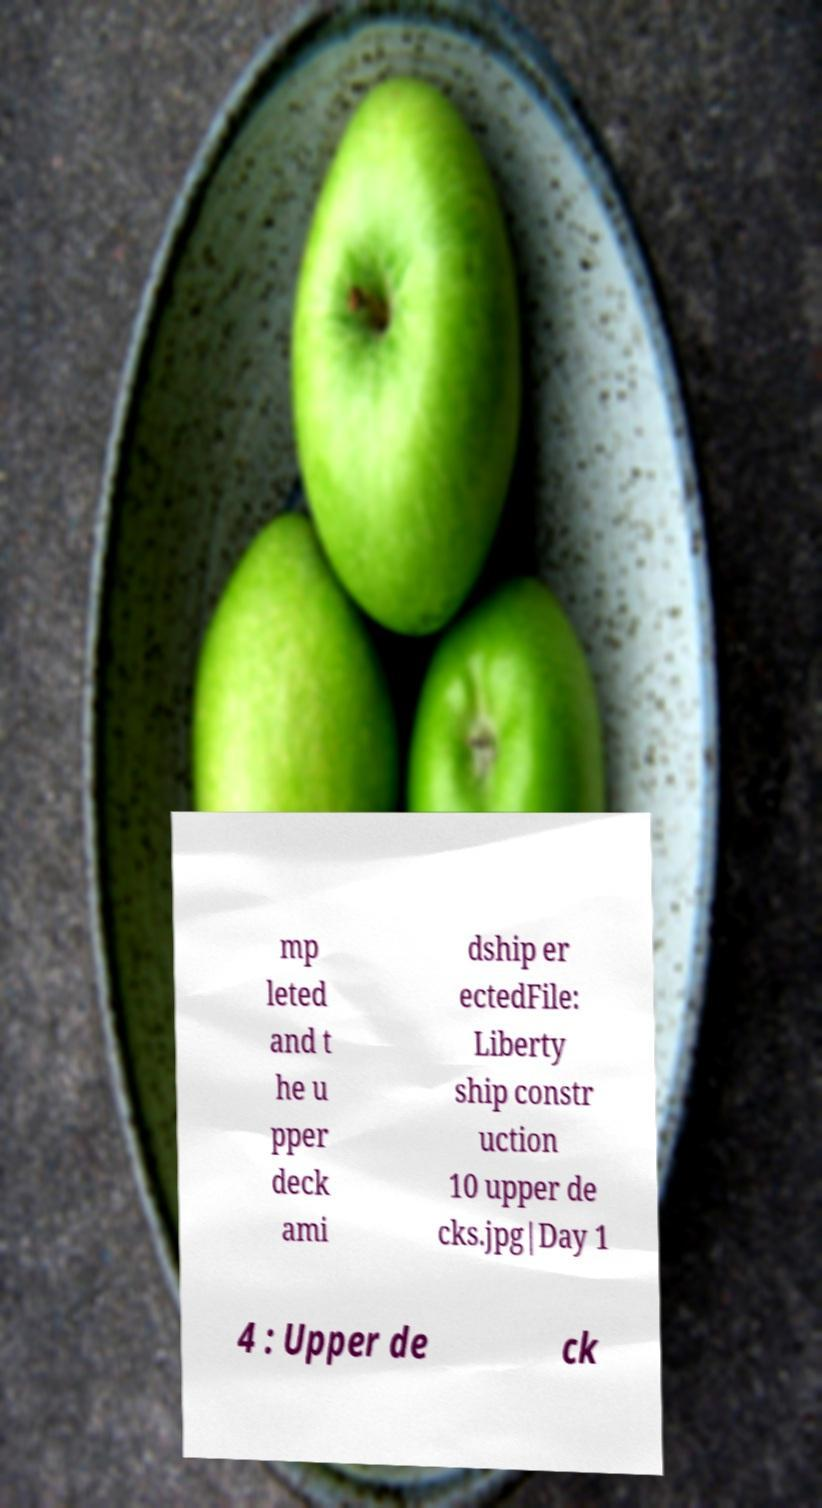Please identify and transcribe the text found in this image. mp leted and t he u pper deck ami dship er ectedFile: Liberty ship constr uction 10 upper de cks.jpg|Day 1 4 : Upper de ck 